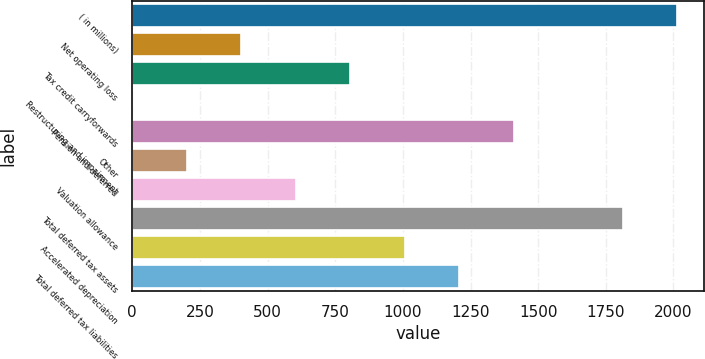<chart> <loc_0><loc_0><loc_500><loc_500><bar_chart><fcel>( in millions)<fcel>Net operating loss<fcel>Tax credit carryforwards<fcel>Restructuring and impairment<fcel>Pension and deferred<fcel>Other<fcel>Valuation allowance<fcel>Total deferred tax assets<fcel>Accelerated depreciation<fcel>Total deferred tax liabilities<nl><fcel>2013<fcel>402.68<fcel>805.26<fcel>0.1<fcel>1409.13<fcel>201.39<fcel>603.97<fcel>1811.71<fcel>1006.55<fcel>1207.84<nl></chart> 